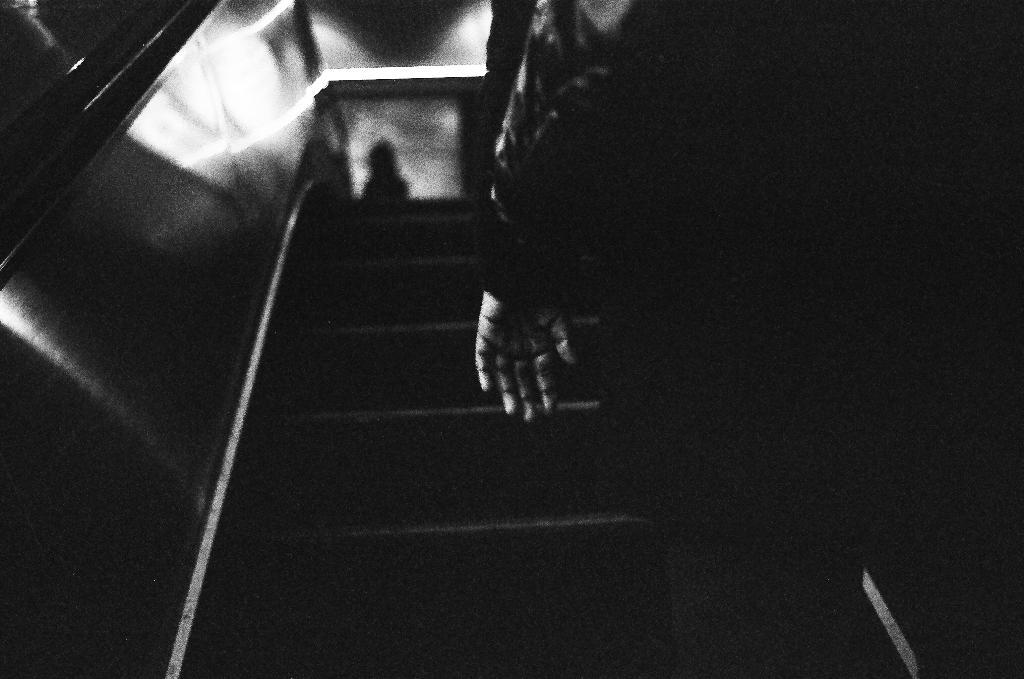What is the color scheme of the image? The picture is black and white. What can be seen in the image? There is a person standing on an escalator in the image. What type of cream is being sold in the shop in the image? There is no shop present in the image, and therefore no cream being sold. What day of the week is it in the image? The day of the week is not mentioned or depicted in the image. 